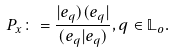Convert formula to latex. <formula><loc_0><loc_0><loc_500><loc_500>P _ { x } \colon = \frac { | e _ { q } ) ( e _ { q } | } { ( e _ { q } | e _ { q } ) } , q \in \mathbb { L } _ { o } .</formula> 